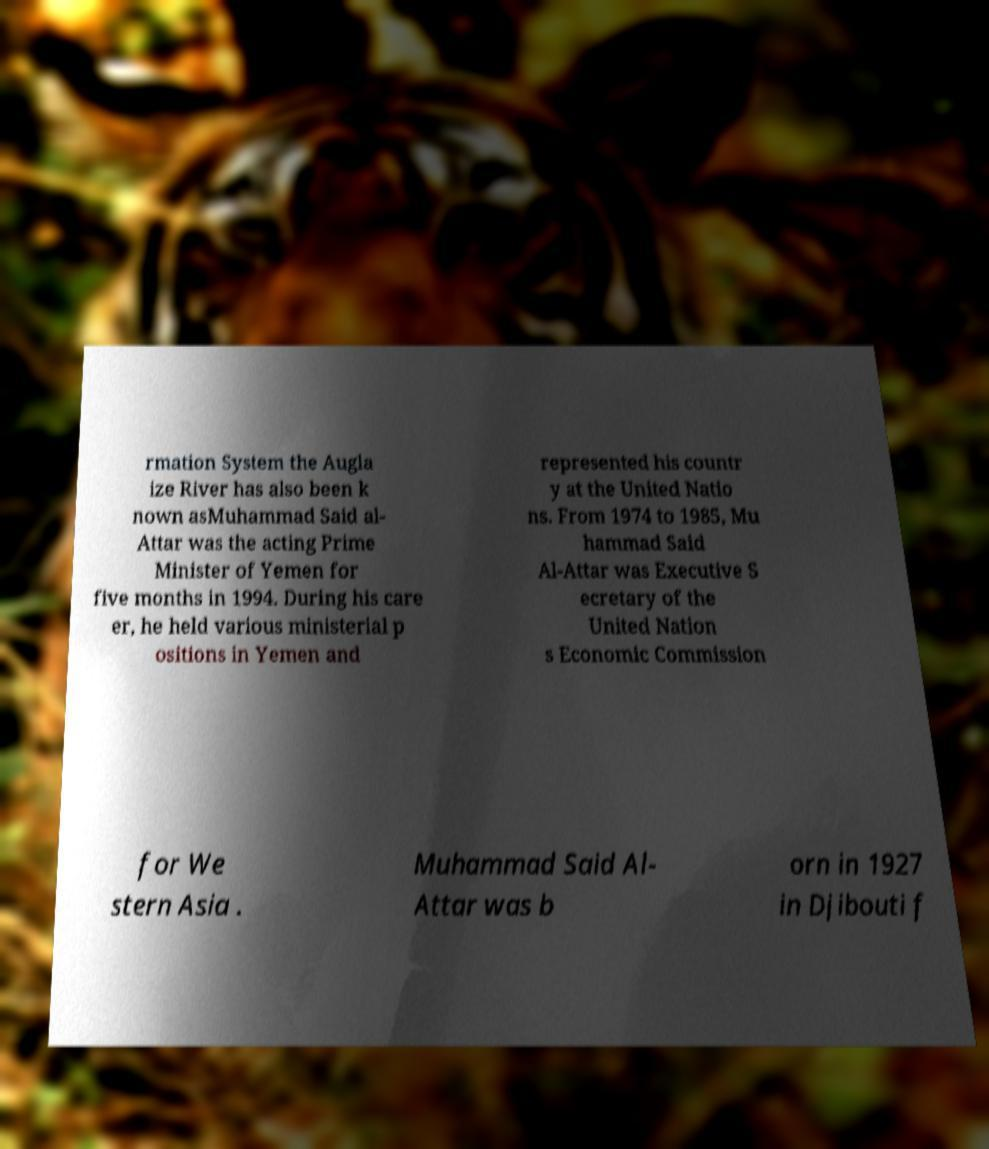Could you assist in decoding the text presented in this image and type it out clearly? rmation System the Augla ize River has also been k nown asMuhammad Said al- Attar was the acting Prime Minister of Yemen for five months in 1994. During his care er, he held various ministerial p ositions in Yemen and represented his countr y at the United Natio ns. From 1974 to 1985, Mu hammad Said Al-Attar was Executive S ecretary of the United Nation s Economic Commission for We stern Asia . Muhammad Said Al- Attar was b orn in 1927 in Djibouti f 